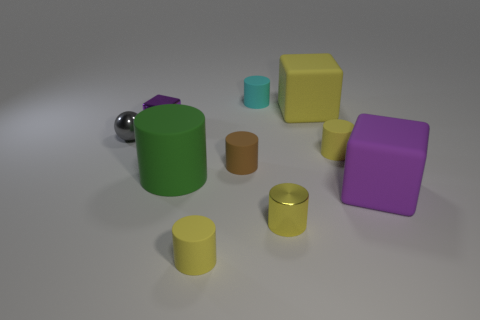Are there any small brown things that are to the left of the purple block in front of the tiny purple cube?
Your answer should be very brief. Yes. There is a small matte thing that is in front of the tiny metallic cylinder; is its shape the same as the tiny purple thing?
Offer a very short reply. No. What is the shape of the big yellow matte thing?
Make the answer very short. Cube. What number of small purple objects have the same material as the sphere?
Ensure brevity in your answer.  1. Is the color of the small ball the same as the small rubber cylinder that is in front of the green cylinder?
Ensure brevity in your answer.  No. What number of blue rubber cylinders are there?
Provide a succinct answer. 0. Are there any small shiny objects of the same color as the tiny shiny cylinder?
Offer a very short reply. No. What is the color of the large matte thing that is on the right side of the block that is behind the tiny purple cube that is on the left side of the big yellow object?
Offer a terse response. Purple. Do the tiny cube and the yellow cylinder on the right side of the big yellow thing have the same material?
Your response must be concise. No. What is the material of the green cylinder?
Ensure brevity in your answer.  Rubber. 